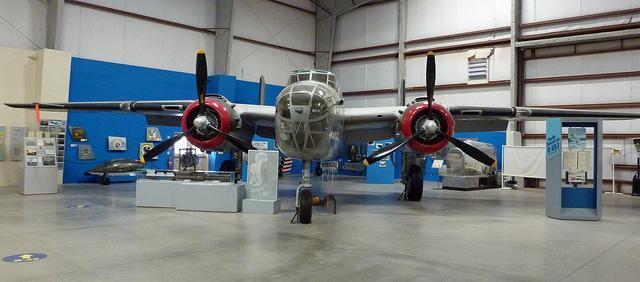How many propellers on the plane?
Give a very brief answer. 2. 